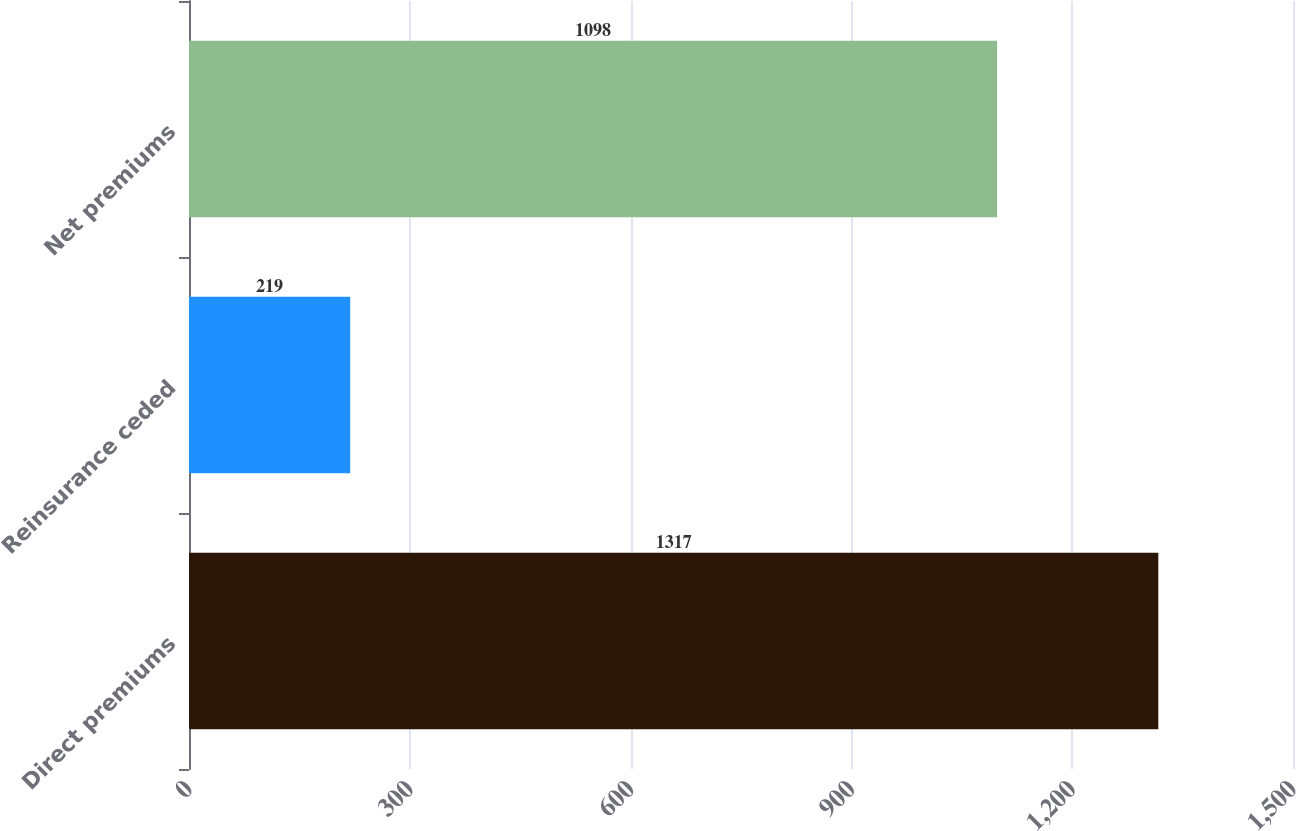Convert chart. <chart><loc_0><loc_0><loc_500><loc_500><bar_chart><fcel>Direct premiums<fcel>Reinsurance ceded<fcel>Net premiums<nl><fcel>1317<fcel>219<fcel>1098<nl></chart> 